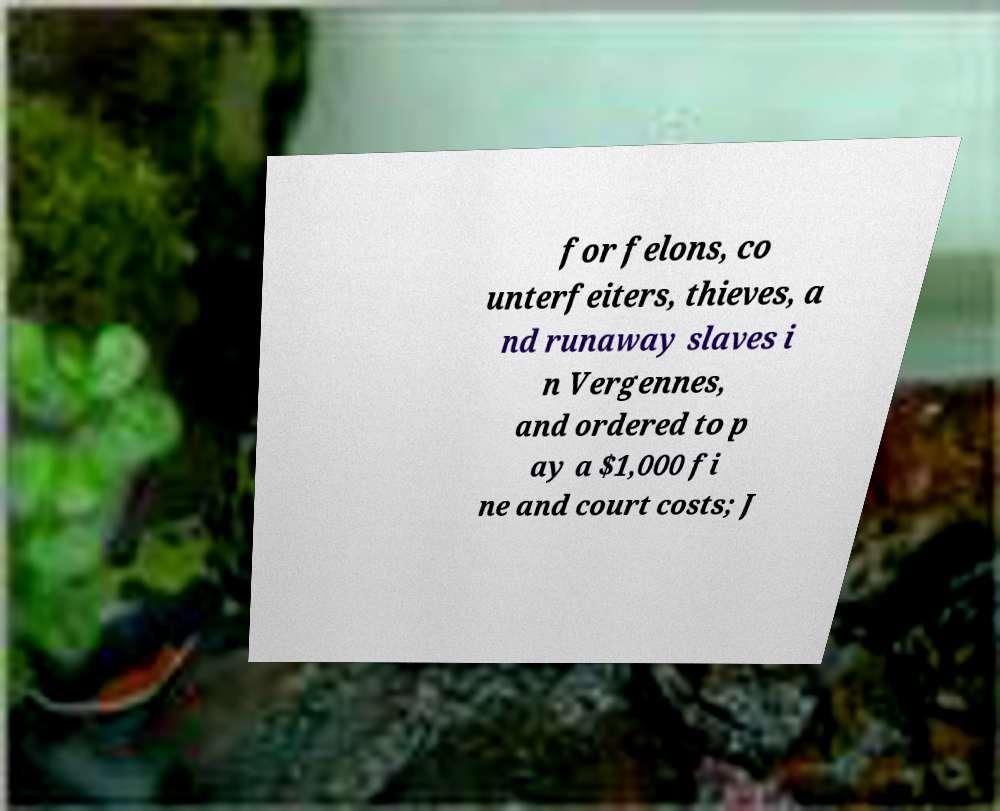Could you assist in decoding the text presented in this image and type it out clearly? for felons, co unterfeiters, thieves, a nd runaway slaves i n Vergennes, and ordered to p ay a $1,000 fi ne and court costs; J 